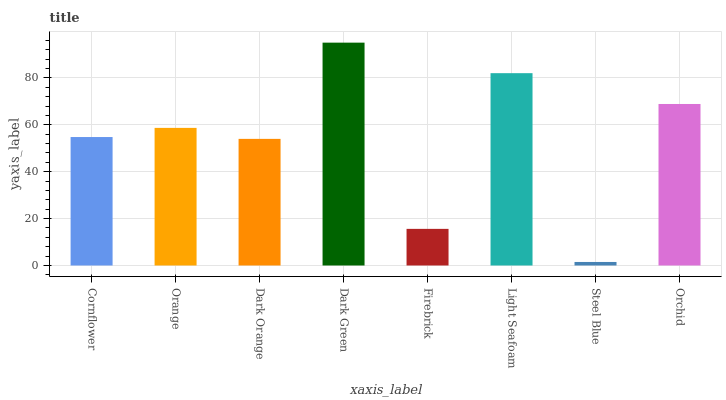Is Steel Blue the minimum?
Answer yes or no. Yes. Is Dark Green the maximum?
Answer yes or no. Yes. Is Orange the minimum?
Answer yes or no. No. Is Orange the maximum?
Answer yes or no. No. Is Orange greater than Cornflower?
Answer yes or no. Yes. Is Cornflower less than Orange?
Answer yes or no. Yes. Is Cornflower greater than Orange?
Answer yes or no. No. Is Orange less than Cornflower?
Answer yes or no. No. Is Orange the high median?
Answer yes or no. Yes. Is Cornflower the low median?
Answer yes or no. Yes. Is Steel Blue the high median?
Answer yes or no. No. Is Dark Orange the low median?
Answer yes or no. No. 